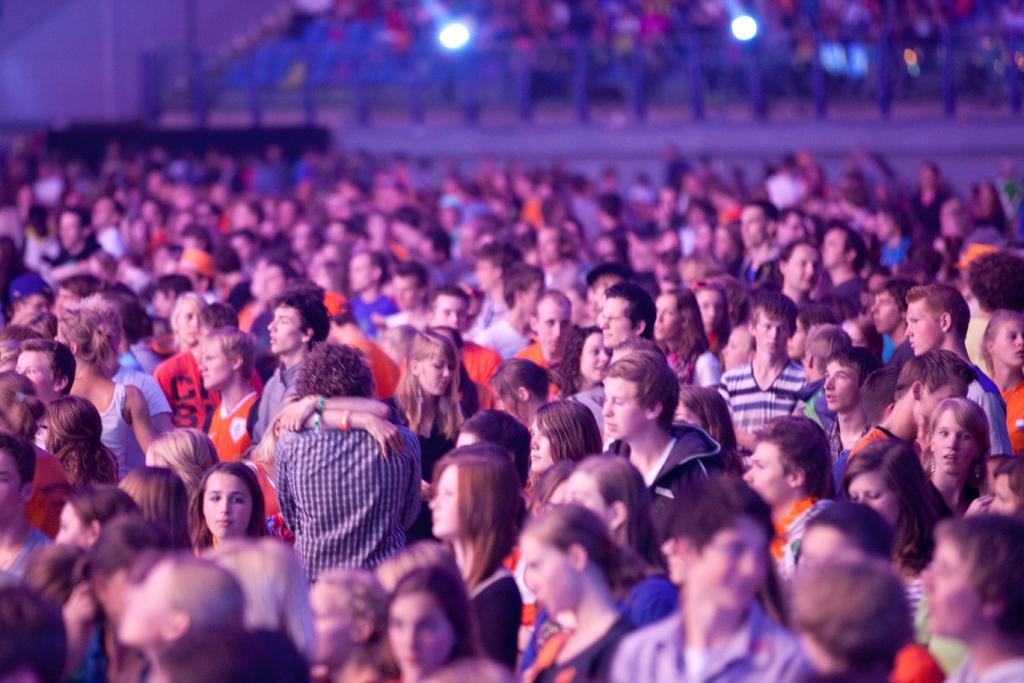Describe this image in one or two sentences. In this image we can see many persons standing on the ground. In the background we can see fencing, lights and persons. 